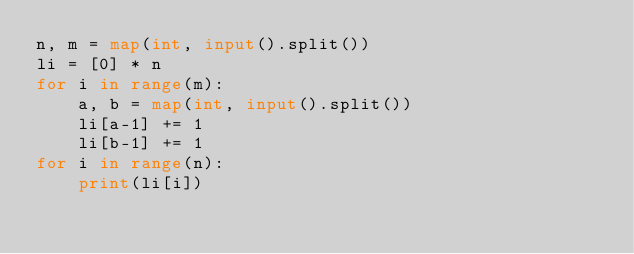Convert code to text. <code><loc_0><loc_0><loc_500><loc_500><_Python_>n, m = map(int, input().split())
li = [0] * n
for i in range(m):
    a, b = map(int, input().split())
    li[a-1] += 1
    li[b-1] += 1
for i in range(n):
    print(li[i])</code> 